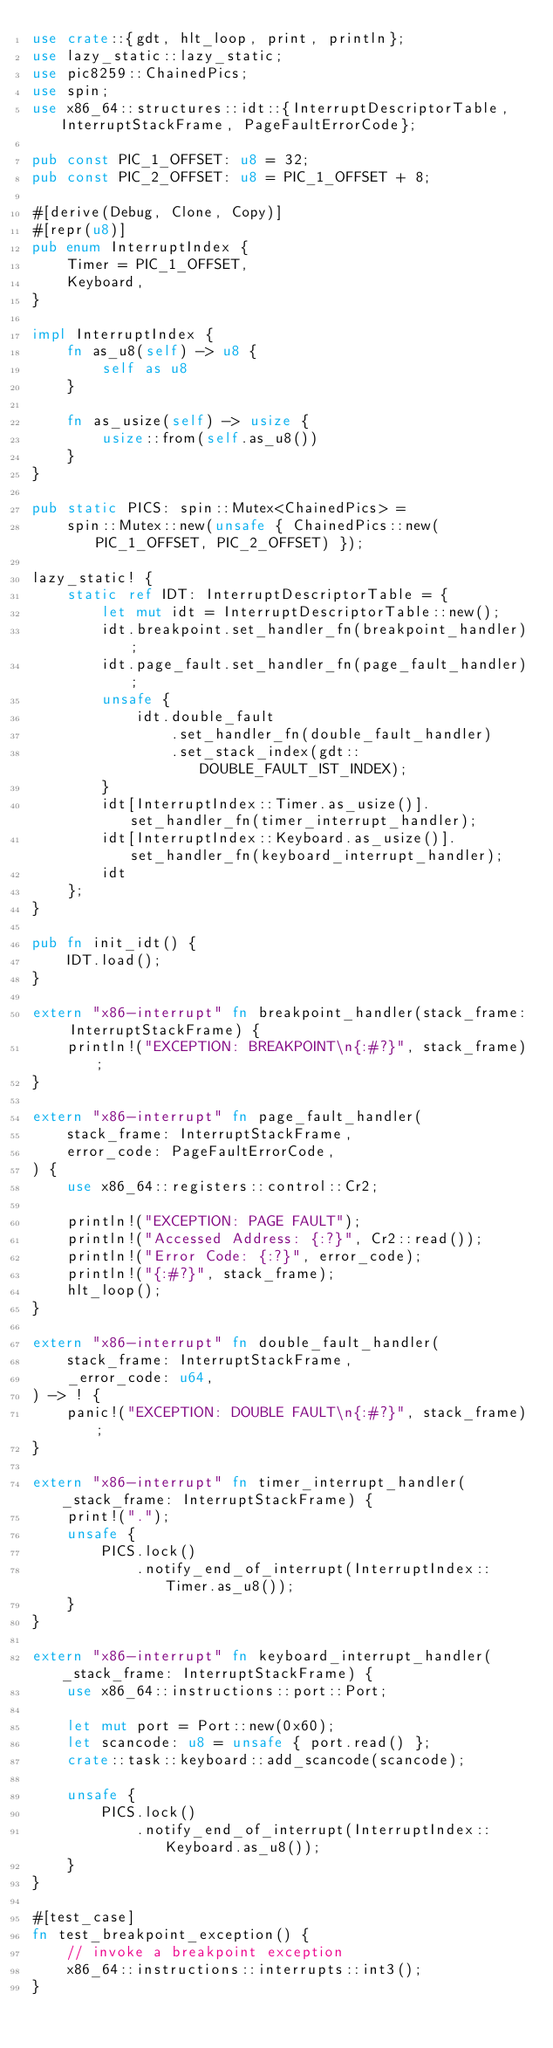<code> <loc_0><loc_0><loc_500><loc_500><_Rust_>use crate::{gdt, hlt_loop, print, println};
use lazy_static::lazy_static;
use pic8259::ChainedPics;
use spin;
use x86_64::structures::idt::{InterruptDescriptorTable, InterruptStackFrame, PageFaultErrorCode};

pub const PIC_1_OFFSET: u8 = 32;
pub const PIC_2_OFFSET: u8 = PIC_1_OFFSET + 8;

#[derive(Debug, Clone, Copy)]
#[repr(u8)]
pub enum InterruptIndex {
    Timer = PIC_1_OFFSET,
    Keyboard,
}

impl InterruptIndex {
    fn as_u8(self) -> u8 {
        self as u8
    }

    fn as_usize(self) -> usize {
        usize::from(self.as_u8())
    }
}

pub static PICS: spin::Mutex<ChainedPics> =
    spin::Mutex::new(unsafe { ChainedPics::new(PIC_1_OFFSET, PIC_2_OFFSET) });

lazy_static! {
    static ref IDT: InterruptDescriptorTable = {
        let mut idt = InterruptDescriptorTable::new();
        idt.breakpoint.set_handler_fn(breakpoint_handler);
        idt.page_fault.set_handler_fn(page_fault_handler);
        unsafe {
            idt.double_fault
                .set_handler_fn(double_fault_handler)
                .set_stack_index(gdt::DOUBLE_FAULT_IST_INDEX);
        }
        idt[InterruptIndex::Timer.as_usize()].set_handler_fn(timer_interrupt_handler);
        idt[InterruptIndex::Keyboard.as_usize()].set_handler_fn(keyboard_interrupt_handler);
        idt
    };
}

pub fn init_idt() {
    IDT.load();
}

extern "x86-interrupt" fn breakpoint_handler(stack_frame: InterruptStackFrame) {
    println!("EXCEPTION: BREAKPOINT\n{:#?}", stack_frame);
}

extern "x86-interrupt" fn page_fault_handler(
    stack_frame: InterruptStackFrame,
    error_code: PageFaultErrorCode,
) {
    use x86_64::registers::control::Cr2;

    println!("EXCEPTION: PAGE FAULT");
    println!("Accessed Address: {:?}", Cr2::read());
    println!("Error Code: {:?}", error_code);
    println!("{:#?}", stack_frame);
    hlt_loop();
}

extern "x86-interrupt" fn double_fault_handler(
    stack_frame: InterruptStackFrame,
    _error_code: u64,
) -> ! {
    panic!("EXCEPTION: DOUBLE FAULT\n{:#?}", stack_frame);
}

extern "x86-interrupt" fn timer_interrupt_handler(_stack_frame: InterruptStackFrame) {
    print!(".");
    unsafe {
        PICS.lock()
            .notify_end_of_interrupt(InterruptIndex::Timer.as_u8());
    }
}

extern "x86-interrupt" fn keyboard_interrupt_handler(_stack_frame: InterruptStackFrame) {
    use x86_64::instructions::port::Port;

    let mut port = Port::new(0x60);
    let scancode: u8 = unsafe { port.read() };
    crate::task::keyboard::add_scancode(scancode);

    unsafe {
        PICS.lock()
            .notify_end_of_interrupt(InterruptIndex::Keyboard.as_u8());
    }
}

#[test_case]
fn test_breakpoint_exception() {
    // invoke a breakpoint exception
    x86_64::instructions::interrupts::int3();
}
</code> 